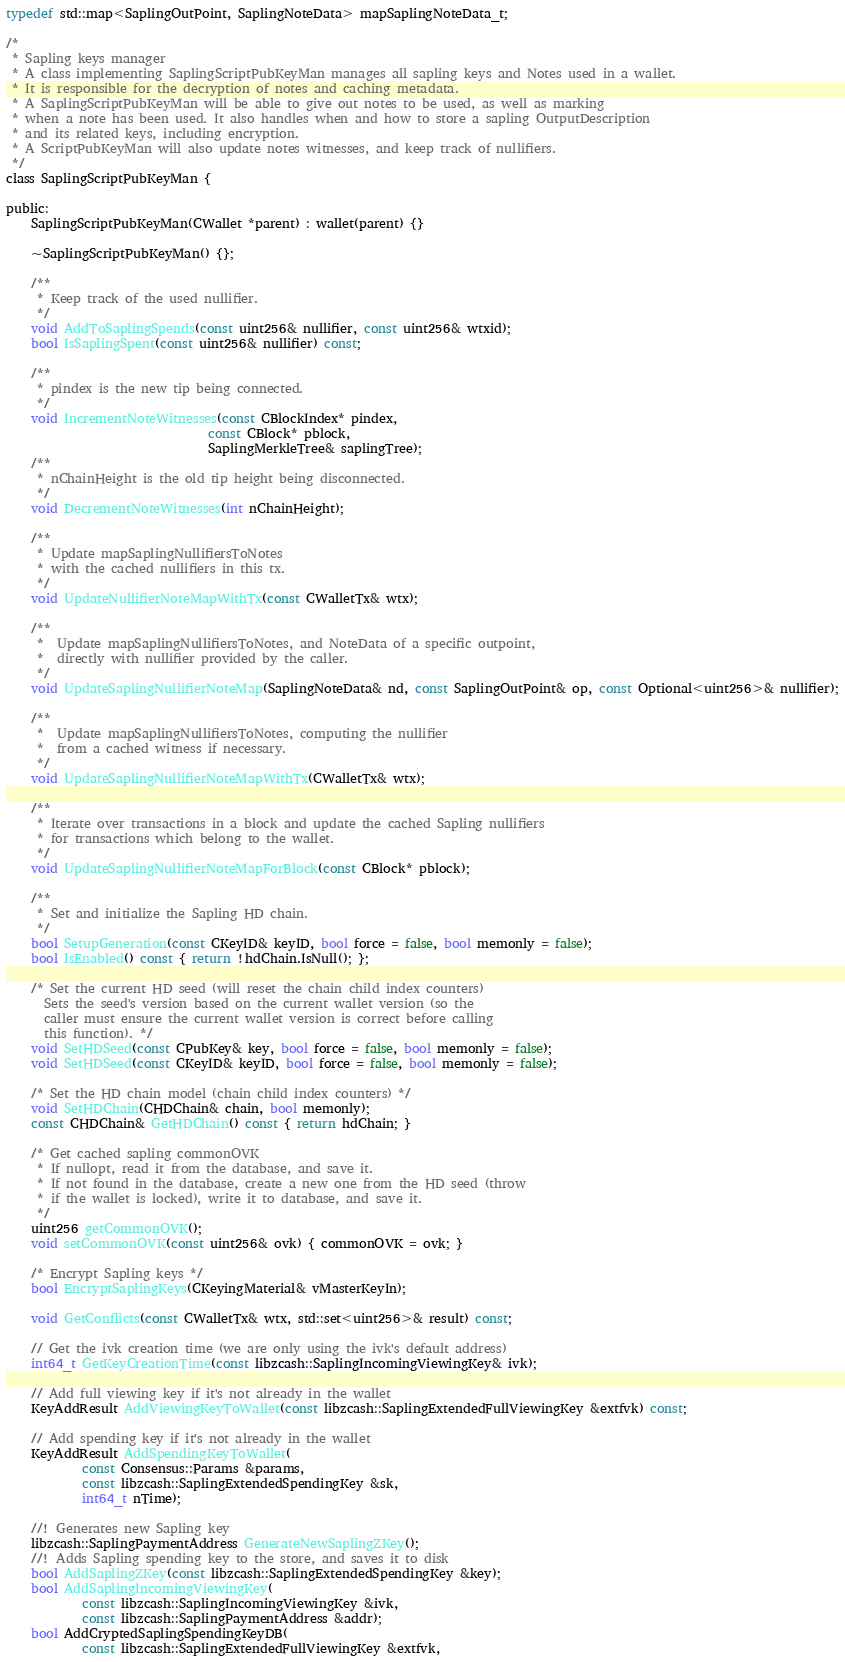<code> <loc_0><loc_0><loc_500><loc_500><_C_>
typedef std::map<SaplingOutPoint, SaplingNoteData> mapSaplingNoteData_t;

/*
 * Sapling keys manager
 * A class implementing SaplingScriptPubKeyMan manages all sapling keys and Notes used in a wallet.
 * It is responsible for the decryption of notes and caching metadata.
 * A SaplingScriptPubKeyMan will be able to give out notes to be used, as well as marking
 * when a note has been used. It also handles when and how to store a sapling OutputDescription
 * and its related keys, including encryption.
 * A ScriptPubKeyMan will also update notes witnesses, and keep track of nullifiers.
 */
class SaplingScriptPubKeyMan {

public:
    SaplingScriptPubKeyMan(CWallet *parent) : wallet(parent) {}

    ~SaplingScriptPubKeyMan() {};

    /**
     * Keep track of the used nullifier.
     */
    void AddToSaplingSpends(const uint256& nullifier, const uint256& wtxid);
    bool IsSaplingSpent(const uint256& nullifier) const;

    /**
     * pindex is the new tip being connected.
     */
    void IncrementNoteWitnesses(const CBlockIndex* pindex,
                                const CBlock* pblock,
                                SaplingMerkleTree& saplingTree);
    /**
     * nChainHeight is the old tip height being disconnected.
     */
    void DecrementNoteWitnesses(int nChainHeight);

    /**
     * Update mapSaplingNullifiersToNotes
     * with the cached nullifiers in this tx.
     */
    void UpdateNullifierNoteMapWithTx(const CWalletTx& wtx);

    /**
     *  Update mapSaplingNullifiersToNotes, and NoteData of a specific outpoint,
     *  directly with nullifier provided by the caller.
     */
    void UpdateSaplingNullifierNoteMap(SaplingNoteData& nd, const SaplingOutPoint& op, const Optional<uint256>& nullifier);

    /**
     *  Update mapSaplingNullifiersToNotes, computing the nullifier
     *  from a cached witness if necessary.
     */
    void UpdateSaplingNullifierNoteMapWithTx(CWalletTx& wtx);

    /**
     * Iterate over transactions in a block and update the cached Sapling nullifiers
     * for transactions which belong to the wallet.
     */
    void UpdateSaplingNullifierNoteMapForBlock(const CBlock* pblock);

    /**
     * Set and initialize the Sapling HD chain.
     */
    bool SetupGeneration(const CKeyID& keyID, bool force = false, bool memonly = false);
    bool IsEnabled() const { return !hdChain.IsNull(); };

    /* Set the current HD seed (will reset the chain child index counters)
      Sets the seed's version based on the current wallet version (so the
      caller must ensure the current wallet version is correct before calling
      this function). */
    void SetHDSeed(const CPubKey& key, bool force = false, bool memonly = false);
    void SetHDSeed(const CKeyID& keyID, bool force = false, bool memonly = false);

    /* Set the HD chain model (chain child index counters) */
    void SetHDChain(CHDChain& chain, bool memonly);
    const CHDChain& GetHDChain() const { return hdChain; }

    /* Get cached sapling commonOVK
     * If nullopt, read it from the database, and save it.
     * If not found in the database, create a new one from the HD seed (throw
     * if the wallet is locked), write it to database, and save it.
     */
    uint256 getCommonOVK();
    void setCommonOVK(const uint256& ovk) { commonOVK = ovk; }

    /* Encrypt Sapling keys */
    bool EncryptSaplingKeys(CKeyingMaterial& vMasterKeyIn);

    void GetConflicts(const CWalletTx& wtx, std::set<uint256>& result) const;

    // Get the ivk creation time (we are only using the ivk's default address)
    int64_t GetKeyCreationTime(const libzcash::SaplingIncomingViewingKey& ivk);

    // Add full viewing key if it's not already in the wallet
    KeyAddResult AddViewingKeyToWallet(const libzcash::SaplingExtendedFullViewingKey &extfvk) const;

    // Add spending key if it's not already in the wallet
    KeyAddResult AddSpendingKeyToWallet(
            const Consensus::Params &params,
            const libzcash::SaplingExtendedSpendingKey &sk,
            int64_t nTime);

    //! Generates new Sapling key
    libzcash::SaplingPaymentAddress GenerateNewSaplingZKey();
    //! Adds Sapling spending key to the store, and saves it to disk
    bool AddSaplingZKey(const libzcash::SaplingExtendedSpendingKey &key);
    bool AddSaplingIncomingViewingKey(
            const libzcash::SaplingIncomingViewingKey &ivk,
            const libzcash::SaplingPaymentAddress &addr);
    bool AddCryptedSaplingSpendingKeyDB(
            const libzcash::SaplingExtendedFullViewingKey &extfvk,</code> 